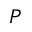Convert formula to latex. <formula><loc_0><loc_0><loc_500><loc_500>P</formula> 